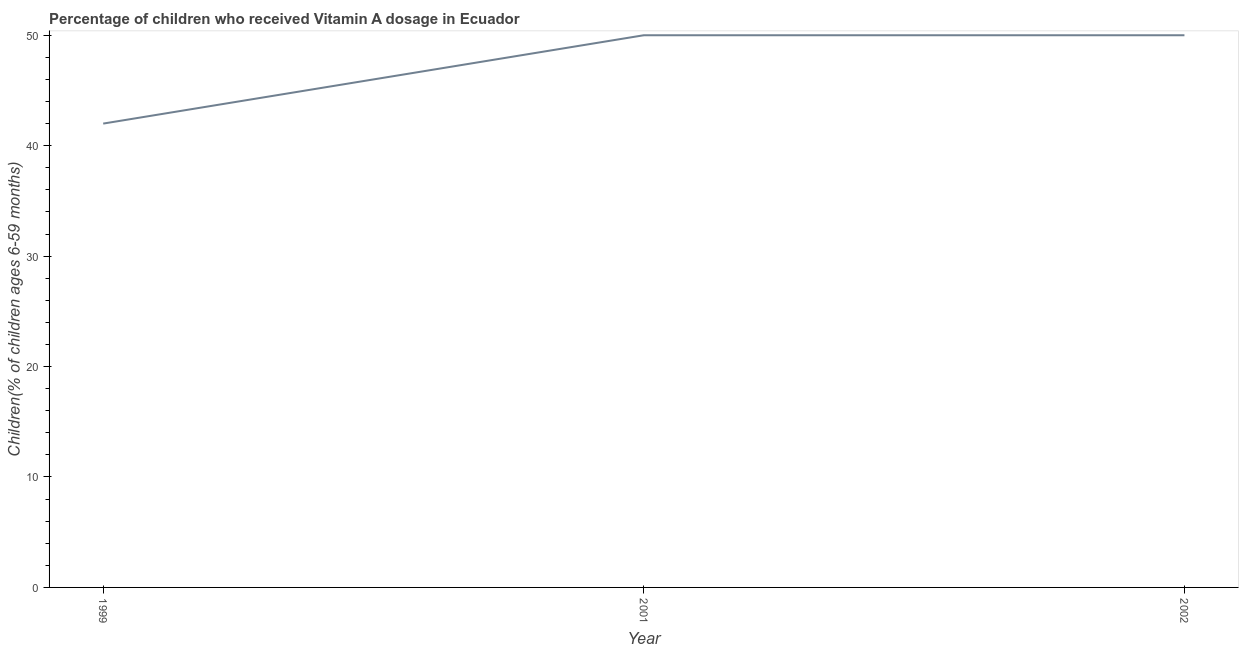What is the vitamin a supplementation coverage rate in 1999?
Your answer should be compact. 42. Across all years, what is the maximum vitamin a supplementation coverage rate?
Offer a terse response. 50. Across all years, what is the minimum vitamin a supplementation coverage rate?
Provide a succinct answer. 42. What is the sum of the vitamin a supplementation coverage rate?
Provide a succinct answer. 142. What is the difference between the vitamin a supplementation coverage rate in 1999 and 2001?
Keep it short and to the point. -8. What is the average vitamin a supplementation coverage rate per year?
Give a very brief answer. 47.33. In how many years, is the vitamin a supplementation coverage rate greater than 46 %?
Provide a short and direct response. 2. What is the ratio of the vitamin a supplementation coverage rate in 1999 to that in 2001?
Make the answer very short. 0.84. Is the difference between the vitamin a supplementation coverage rate in 2001 and 2002 greater than the difference between any two years?
Offer a very short reply. No. What is the difference between the highest and the second highest vitamin a supplementation coverage rate?
Ensure brevity in your answer.  0. What is the difference between the highest and the lowest vitamin a supplementation coverage rate?
Provide a short and direct response. 8. In how many years, is the vitamin a supplementation coverage rate greater than the average vitamin a supplementation coverage rate taken over all years?
Keep it short and to the point. 2. What is the difference between two consecutive major ticks on the Y-axis?
Your answer should be very brief. 10. What is the title of the graph?
Give a very brief answer. Percentage of children who received Vitamin A dosage in Ecuador. What is the label or title of the X-axis?
Your response must be concise. Year. What is the label or title of the Y-axis?
Provide a short and direct response. Children(% of children ages 6-59 months). What is the Children(% of children ages 6-59 months) in 2001?
Your answer should be very brief. 50. What is the difference between the Children(% of children ages 6-59 months) in 1999 and 2001?
Your response must be concise. -8. What is the ratio of the Children(% of children ages 6-59 months) in 1999 to that in 2001?
Offer a very short reply. 0.84. What is the ratio of the Children(% of children ages 6-59 months) in 1999 to that in 2002?
Give a very brief answer. 0.84. 